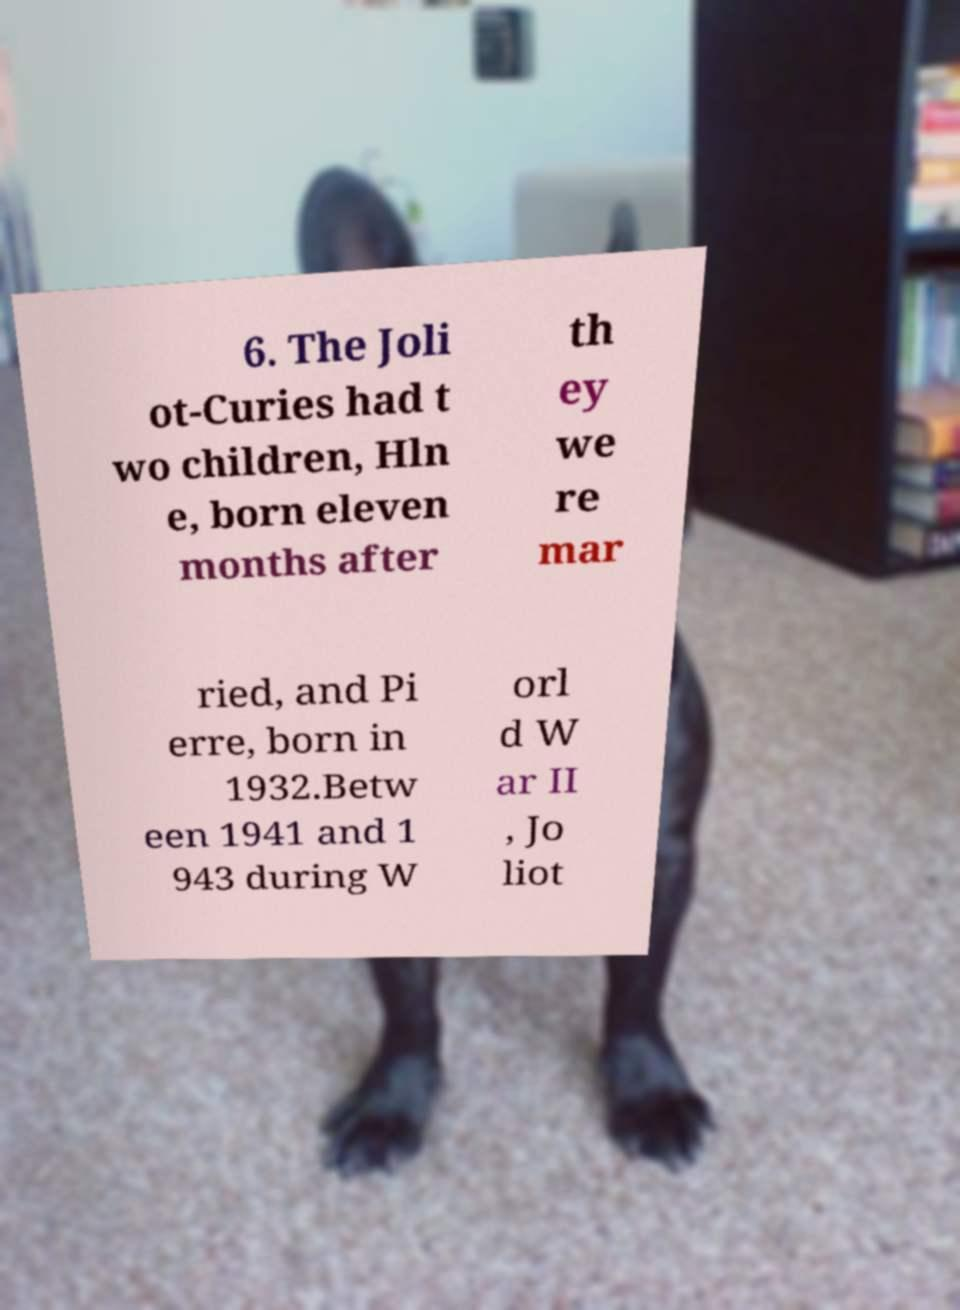For documentation purposes, I need the text within this image transcribed. Could you provide that? 6. The Joli ot-Curies had t wo children, Hln e, born eleven months after th ey we re mar ried, and Pi erre, born in 1932.Betw een 1941 and 1 943 during W orl d W ar II , Jo liot 